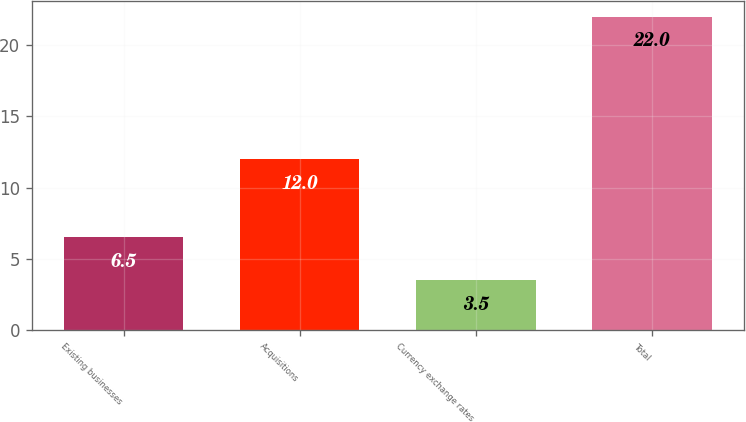<chart> <loc_0><loc_0><loc_500><loc_500><bar_chart><fcel>Existing businesses<fcel>Acquisitions<fcel>Currency exchange rates<fcel>Total<nl><fcel>6.5<fcel>12<fcel>3.5<fcel>22<nl></chart> 